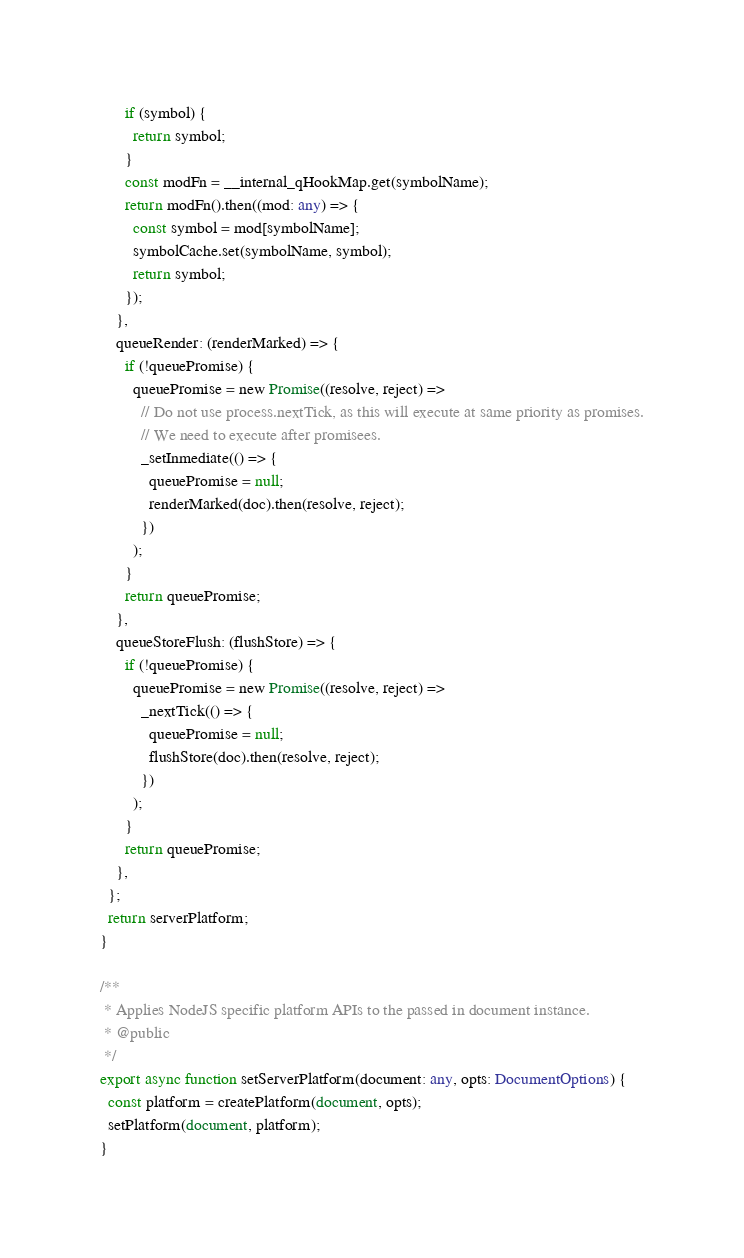<code> <loc_0><loc_0><loc_500><loc_500><_TypeScript_>      if (symbol) {
        return symbol;
      }
      const modFn = __internal_qHookMap.get(symbolName);
      return modFn().then((mod: any) => {
        const symbol = mod[symbolName];
        symbolCache.set(symbolName, symbol);
        return symbol;
      });
    },
    queueRender: (renderMarked) => {
      if (!queuePromise) {
        queuePromise = new Promise((resolve, reject) =>
          // Do not use process.nextTick, as this will execute at same priority as promises.
          // We need to execute after promisees.
          _setInmediate(() => {
            queuePromise = null;
            renderMarked(doc).then(resolve, reject);
          })
        );
      }
      return queuePromise;
    },
    queueStoreFlush: (flushStore) => {
      if (!queuePromise) {
        queuePromise = new Promise((resolve, reject) =>
          _nextTick(() => {
            queuePromise = null;
            flushStore(doc).then(resolve, reject);
          })
        );
      }
      return queuePromise;
    },
  };
  return serverPlatform;
}

/**
 * Applies NodeJS specific platform APIs to the passed in document instance.
 * @public
 */
export async function setServerPlatform(document: any, opts: DocumentOptions) {
  const platform = createPlatform(document, opts);
  setPlatform(document, platform);
}
</code> 